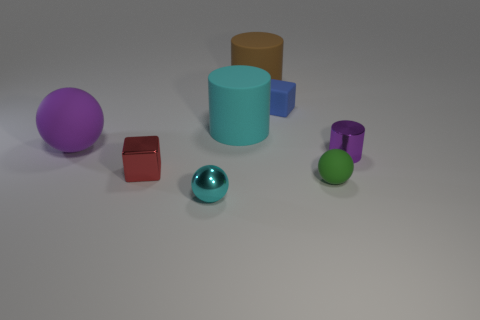The brown object is what size?
Ensure brevity in your answer.  Large. How many purple things are either big cylinders or small rubber balls?
Offer a terse response. 0. What number of blue objects are the same shape as the big purple object?
Make the answer very short. 0. What number of other blocks are the same size as the red metallic cube?
Offer a very short reply. 1. There is a green thing that is the same shape as the large purple object; what is it made of?
Provide a short and direct response. Rubber. The small thing on the right side of the small green matte sphere is what color?
Give a very brief answer. Purple. Are there more tiny things that are right of the big cyan cylinder than large cyan cylinders?
Make the answer very short. Yes. What is the color of the small rubber sphere?
Give a very brief answer. Green. The shiny thing that is to the right of the blue matte thing that is to the right of the tiny sphere that is left of the small green matte ball is what shape?
Your answer should be very brief. Cylinder. What material is the sphere that is both on the left side of the small rubber sphere and on the right side of the metal cube?
Your answer should be compact. Metal. 